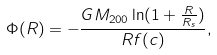<formula> <loc_0><loc_0><loc_500><loc_500>\Phi ( R ) = - \frac { G M _ { 2 0 0 } \ln ( 1 + \frac { R } { R _ { s } } ) } { R f ( c ) } ,</formula> 